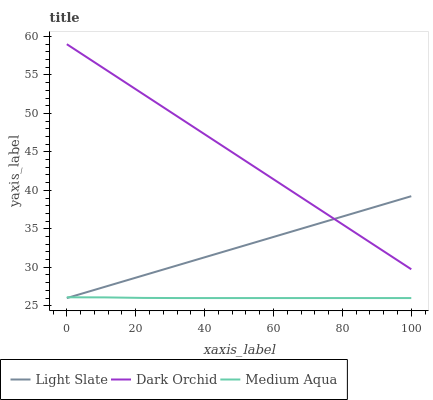Does Medium Aqua have the minimum area under the curve?
Answer yes or no. Yes. Does Dark Orchid have the maximum area under the curve?
Answer yes or no. Yes. Does Dark Orchid have the minimum area under the curve?
Answer yes or no. No. Does Medium Aqua have the maximum area under the curve?
Answer yes or no. No. Is Light Slate the smoothest?
Answer yes or no. Yes. Is Medium Aqua the roughest?
Answer yes or no. Yes. Is Dark Orchid the smoothest?
Answer yes or no. No. Is Dark Orchid the roughest?
Answer yes or no. No. Does Light Slate have the lowest value?
Answer yes or no. Yes. Does Dark Orchid have the lowest value?
Answer yes or no. No. Does Dark Orchid have the highest value?
Answer yes or no. Yes. Does Medium Aqua have the highest value?
Answer yes or no. No. Is Medium Aqua less than Dark Orchid?
Answer yes or no. Yes. Is Dark Orchid greater than Medium Aqua?
Answer yes or no. Yes. Does Light Slate intersect Medium Aqua?
Answer yes or no. Yes. Is Light Slate less than Medium Aqua?
Answer yes or no. No. Is Light Slate greater than Medium Aqua?
Answer yes or no. No. Does Medium Aqua intersect Dark Orchid?
Answer yes or no. No. 